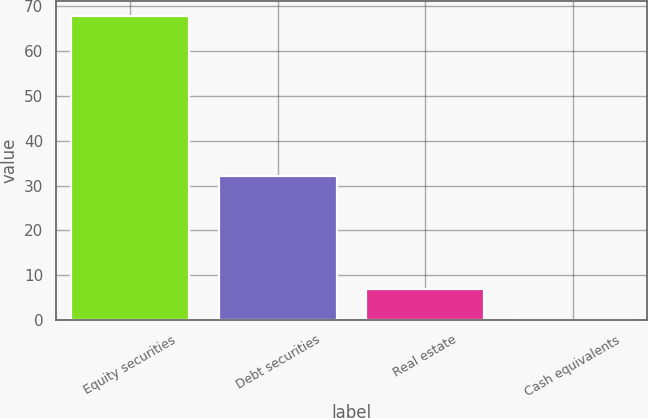Convert chart to OTSL. <chart><loc_0><loc_0><loc_500><loc_500><bar_chart><fcel>Equity securities<fcel>Debt securities<fcel>Real estate<fcel>Cash equivalents<nl><fcel>67.8<fcel>32.1<fcel>6.87<fcel>0.1<nl></chart> 